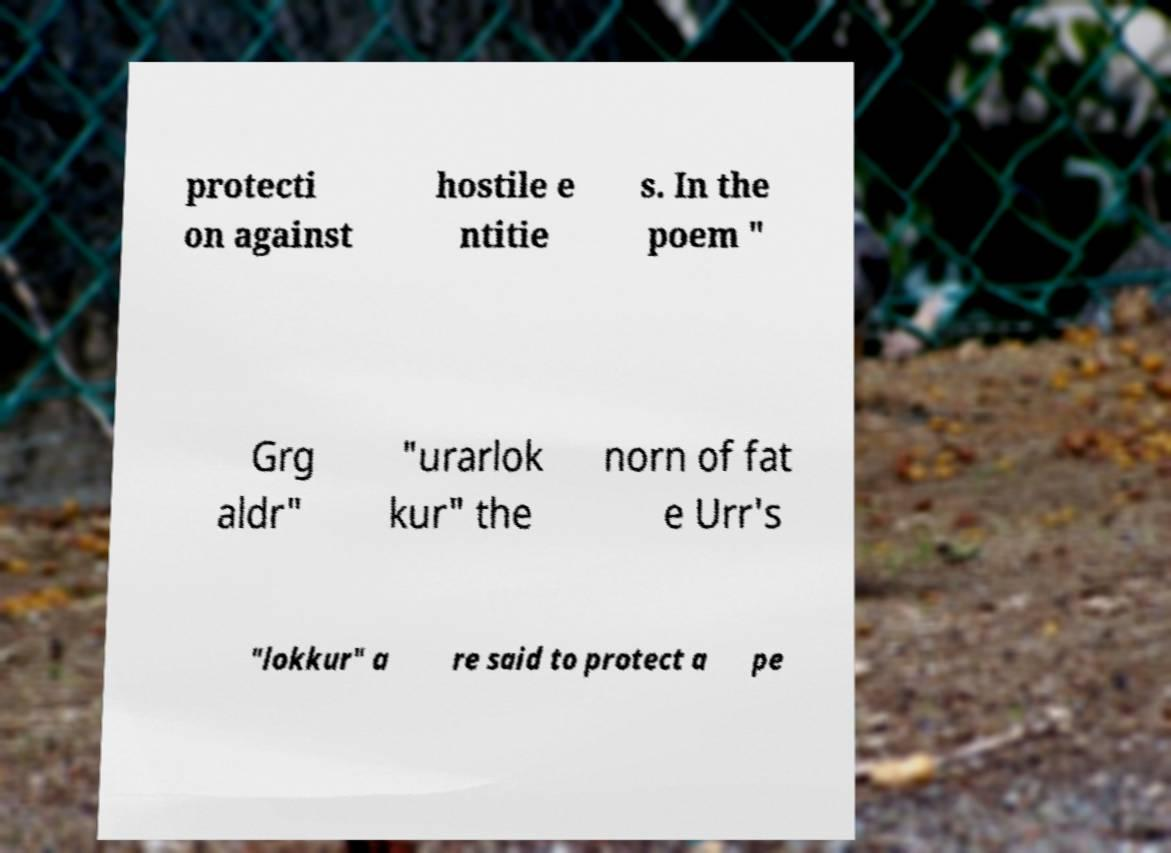Can you accurately transcribe the text from the provided image for me? protecti on against hostile e ntitie s. In the poem " Grg aldr" "urarlok kur" the norn of fat e Urr's "lokkur" a re said to protect a pe 